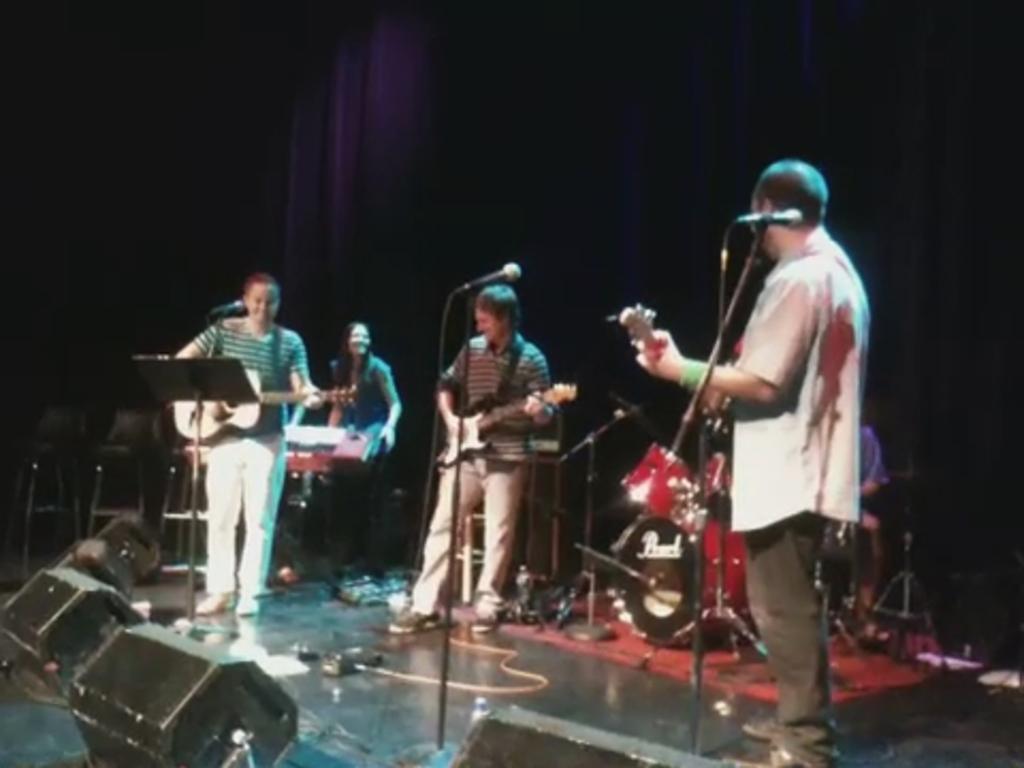Could you give a brief overview of what you see in this image? In the image there are few persons standing on stage and playing guitar with a drum kit and piano behind them and over the back its dark. 